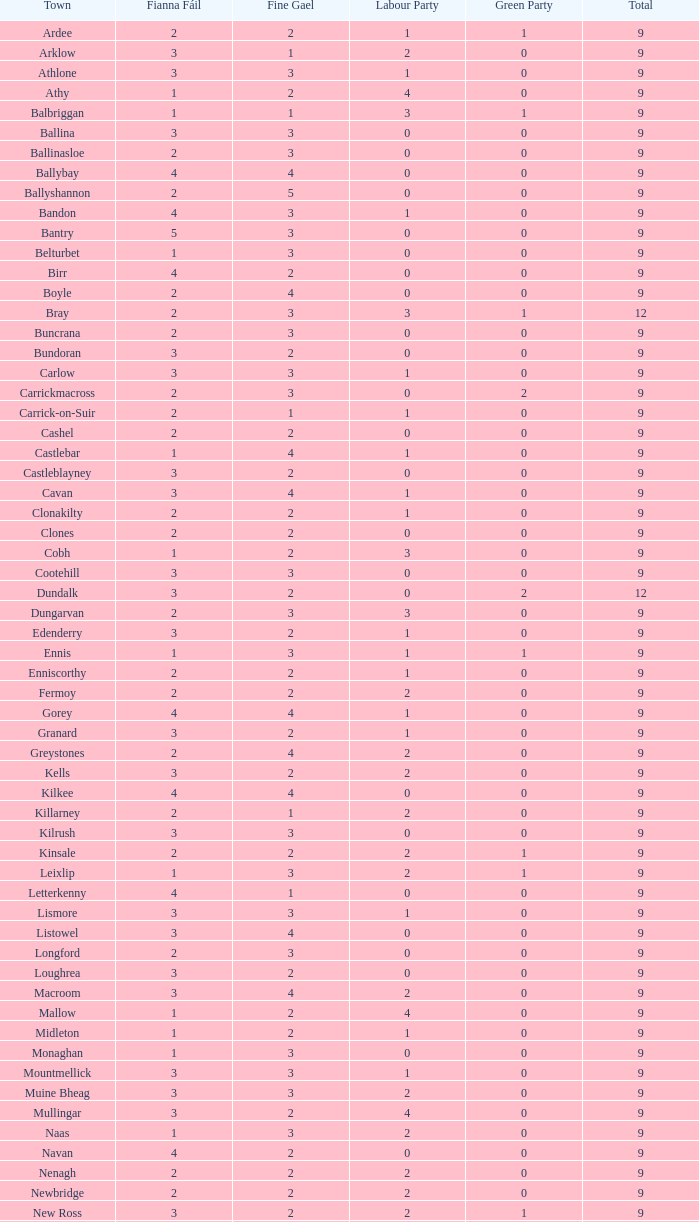In athy, what is the number of green party members with a fine gael rating below 4 and a fianna fail rating below 2? 0.0. 